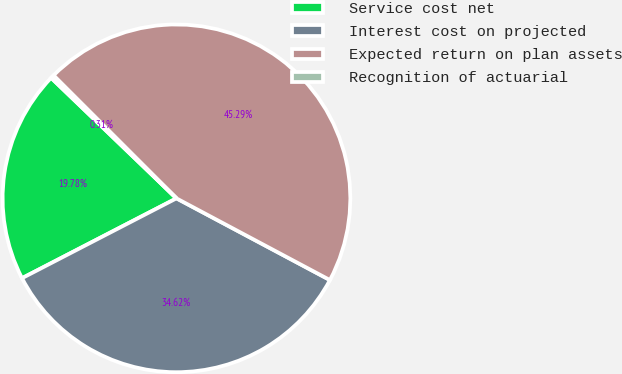<chart> <loc_0><loc_0><loc_500><loc_500><pie_chart><fcel>Service cost net<fcel>Interest cost on projected<fcel>Expected return on plan assets<fcel>Recognition of actuarial<nl><fcel>19.78%<fcel>34.62%<fcel>45.29%<fcel>0.31%<nl></chart> 